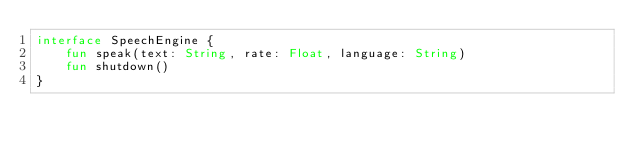Convert code to text. <code><loc_0><loc_0><loc_500><loc_500><_Kotlin_>interface SpeechEngine {
    fun speak(text: String, rate: Float, language: String)
    fun shutdown()
}
</code> 